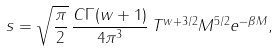<formula> <loc_0><loc_0><loc_500><loc_500>s = \sqrt { \frac { \pi } { 2 } } \, \frac { C \Gamma ( w + 1 ) } { 4 \pi ^ { 3 } } \, T ^ { w + 3 / 2 } M ^ { 5 / 2 } e ^ { - \beta M } ,</formula> 